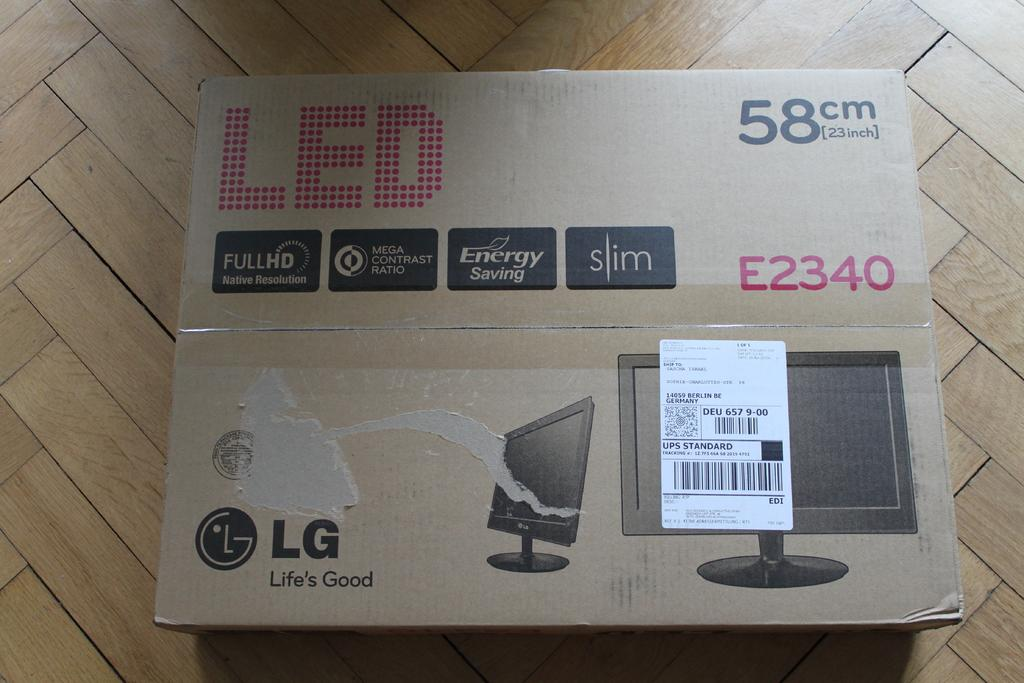<image>
Give a short and clear explanation of the subsequent image. A box has the LG logo in the bottom corner. 